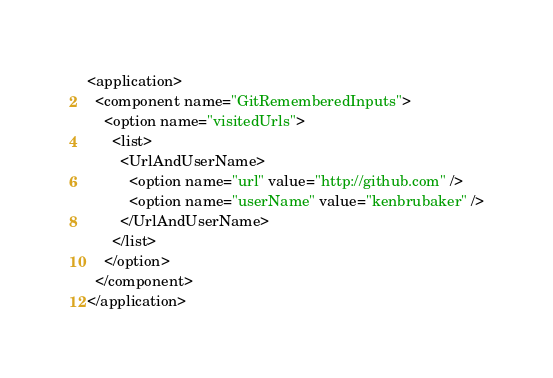<code> <loc_0><loc_0><loc_500><loc_500><_XML_><application>
  <component name="GitRememberedInputs">
    <option name="visitedUrls">
      <list>
        <UrlAndUserName>
          <option name="url" value="http://github.com" />
          <option name="userName" value="kenbrubaker" />
        </UrlAndUserName>
      </list>
    </option>
  </component>
</application></code> 